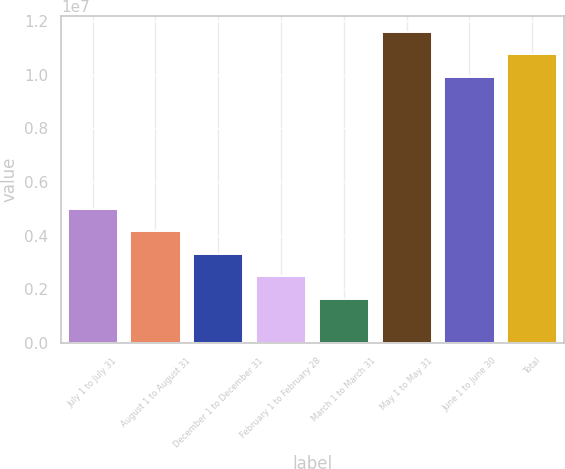Convert chart. <chart><loc_0><loc_0><loc_500><loc_500><bar_chart><fcel>July 1 to July 31<fcel>August 1 to August 31<fcel>December 1 to December 31<fcel>February 1 to February 28<fcel>March 1 to March 31<fcel>May 1 to May 31<fcel>June 1 to June 30<fcel>Total<nl><fcel>4.98802e+06<fcel>4.15269e+06<fcel>3.31735e+06<fcel>2.48202e+06<fcel>1.64669e+06<fcel>1.15916e+07<fcel>9.92098e+06<fcel>1.07563e+07<nl></chart> 